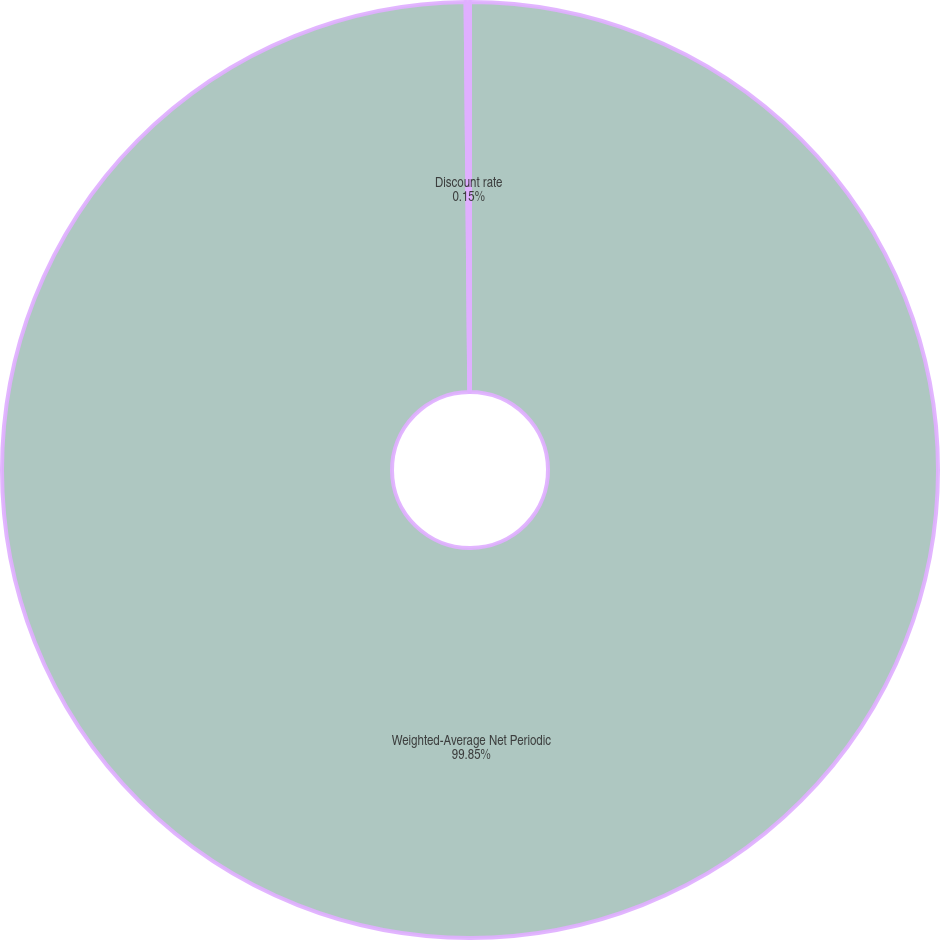Convert chart. <chart><loc_0><loc_0><loc_500><loc_500><pie_chart><fcel>Weighted-Average Net Periodic<fcel>Discount rate<nl><fcel>99.85%<fcel>0.15%<nl></chart> 